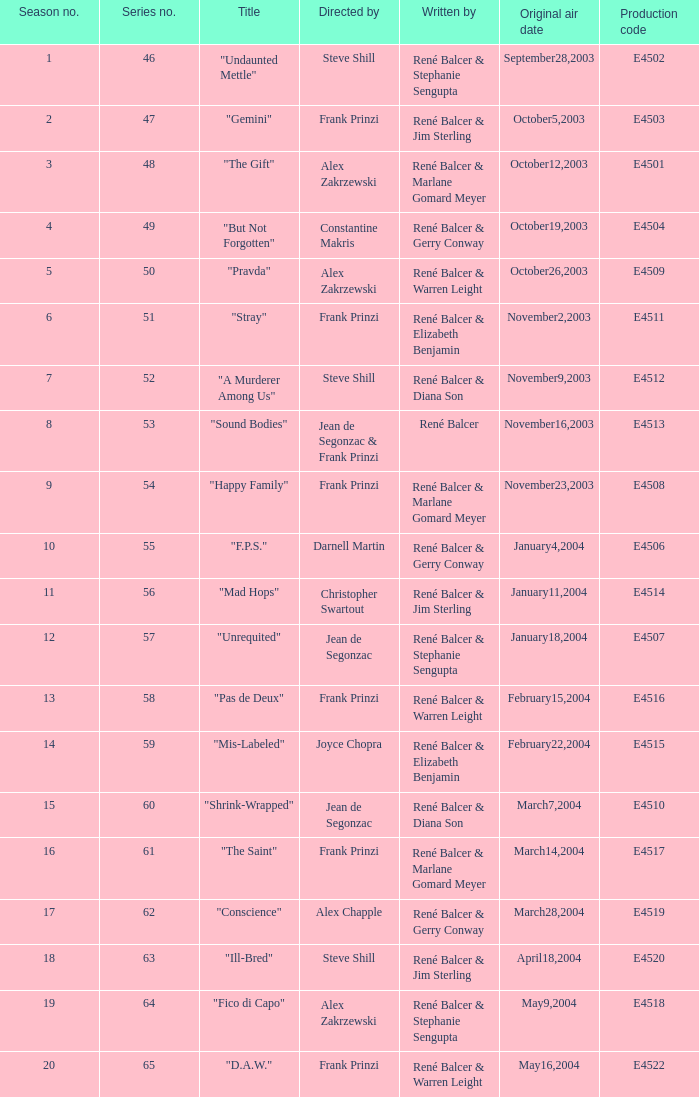What episode number in the season is titled "stray"? 6.0. 